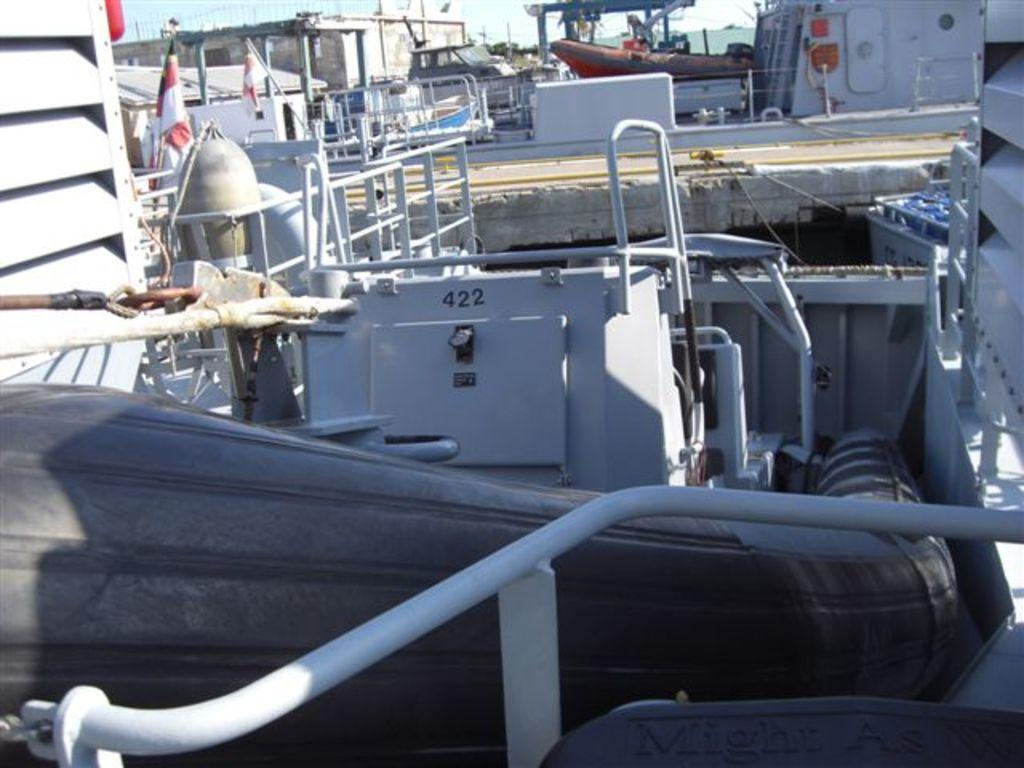What type of structures can be seen in the image? There are poles and pipes in the image. What else can be found in the image? There are containers in the image. Is there any indication of a specific location or event in the image? Yes, there is a flag on a boat in the image. What can be seen in the sky in the image? The sky is visible at the top of the image. Can you see any wounds on the pipes in the image? There are no wounds visible on the pipes in the image; the text does not mention any wounds. 